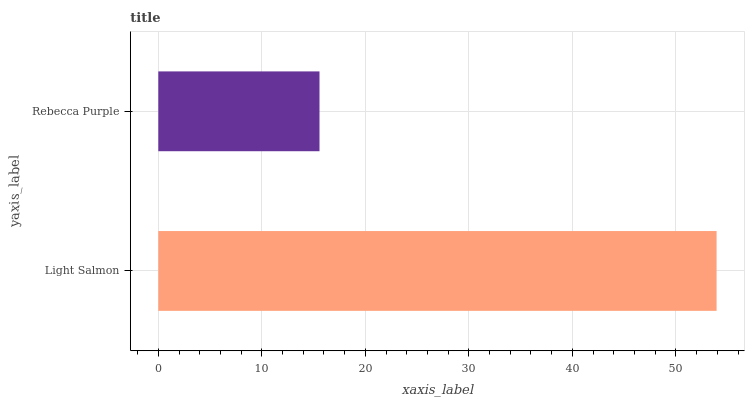Is Rebecca Purple the minimum?
Answer yes or no. Yes. Is Light Salmon the maximum?
Answer yes or no. Yes. Is Rebecca Purple the maximum?
Answer yes or no. No. Is Light Salmon greater than Rebecca Purple?
Answer yes or no. Yes. Is Rebecca Purple less than Light Salmon?
Answer yes or no. Yes. Is Rebecca Purple greater than Light Salmon?
Answer yes or no. No. Is Light Salmon less than Rebecca Purple?
Answer yes or no. No. Is Light Salmon the high median?
Answer yes or no. Yes. Is Rebecca Purple the low median?
Answer yes or no. Yes. Is Rebecca Purple the high median?
Answer yes or no. No. Is Light Salmon the low median?
Answer yes or no. No. 